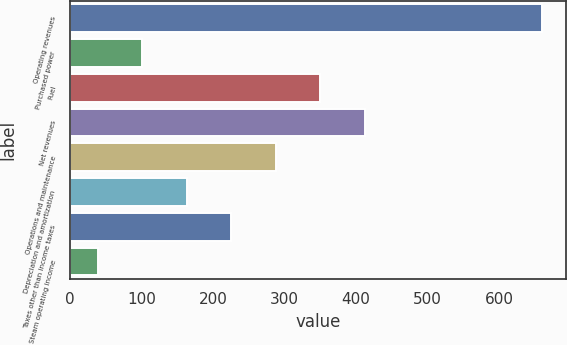Convert chart. <chart><loc_0><loc_0><loc_500><loc_500><bar_chart><fcel>Operating revenues<fcel>Purchased power<fcel>Fuel<fcel>Net revenues<fcel>Operations and maintenance<fcel>Depreciation and amortization<fcel>Taxes other than income taxes<fcel>Steam operating income<nl><fcel>661<fcel>101.2<fcel>350<fcel>412.2<fcel>287.8<fcel>163.4<fcel>225.6<fcel>39<nl></chart> 